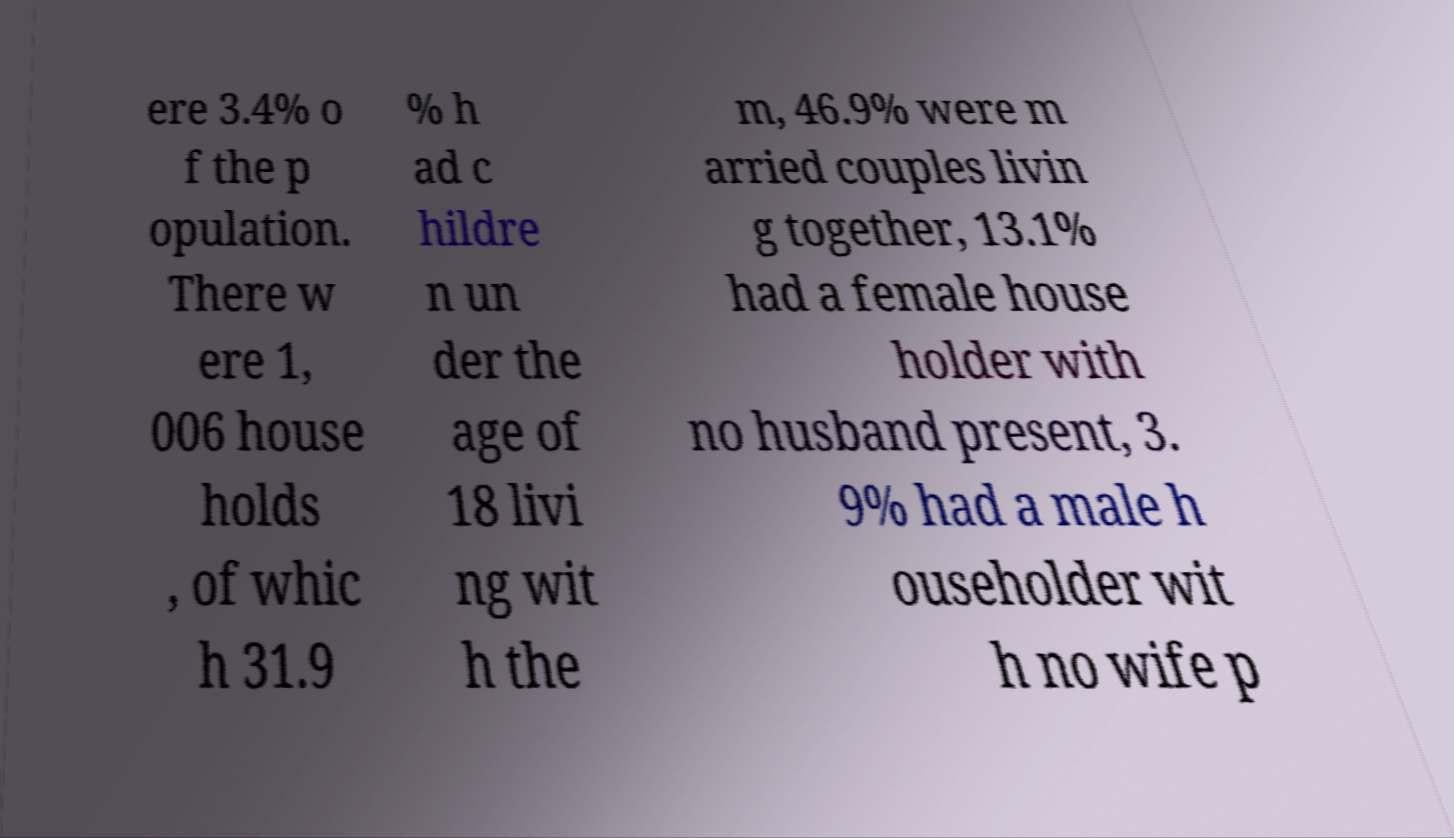Can you read and provide the text displayed in the image?This photo seems to have some interesting text. Can you extract and type it out for me? ere 3.4% o f the p opulation. There w ere 1, 006 house holds , of whic h 31.9 % h ad c hildre n un der the age of 18 livi ng wit h the m, 46.9% were m arried couples livin g together, 13.1% had a female house holder with no husband present, 3. 9% had a male h ouseholder wit h no wife p 